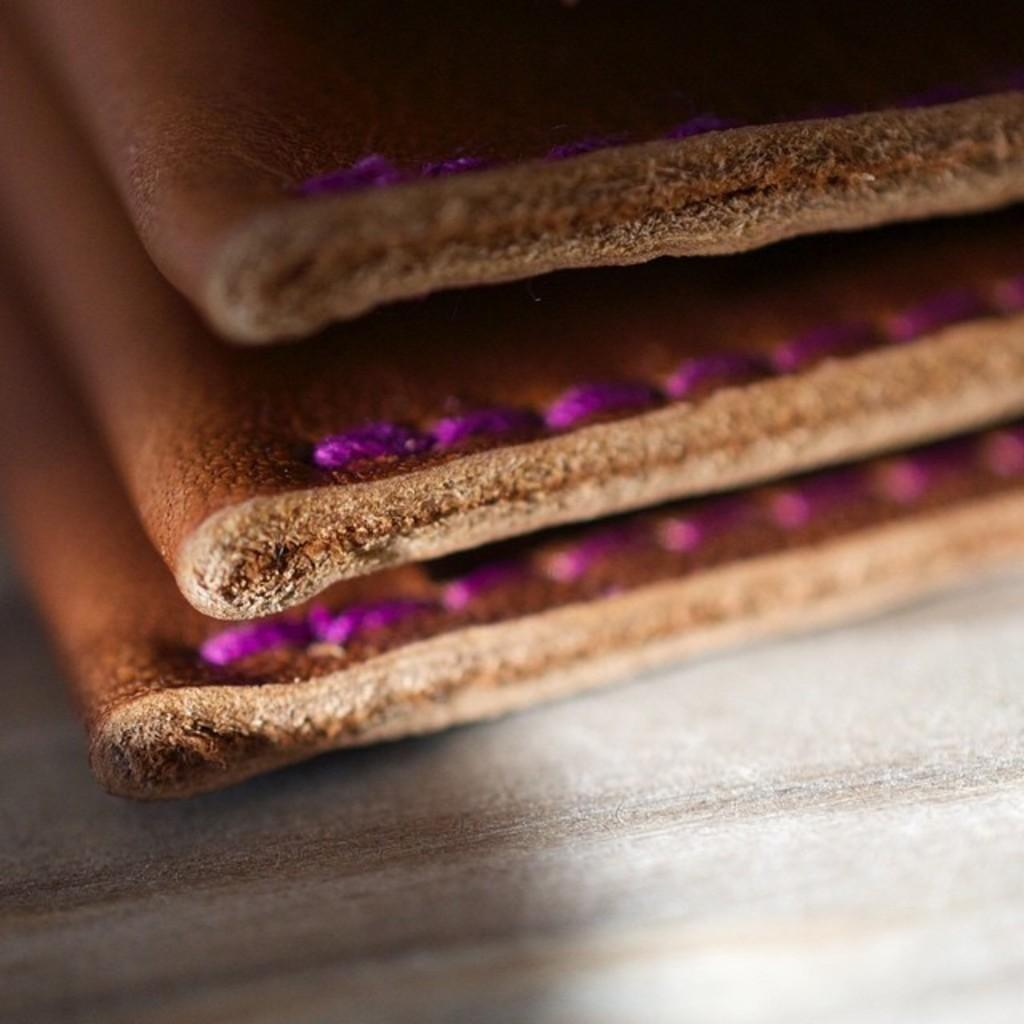What type of material is featured in the image? The image features leather pieces. How are the leather pieces arranged in the image? The leather pieces are placed on a surface. What type of air can be heard in the image? There is no sound, including air, present in the image. What kind of voice can be heard coming from the leather pieces in the image? Leather pieces do not have the ability to produce or convey a voice, so there is no voice present in the image. 